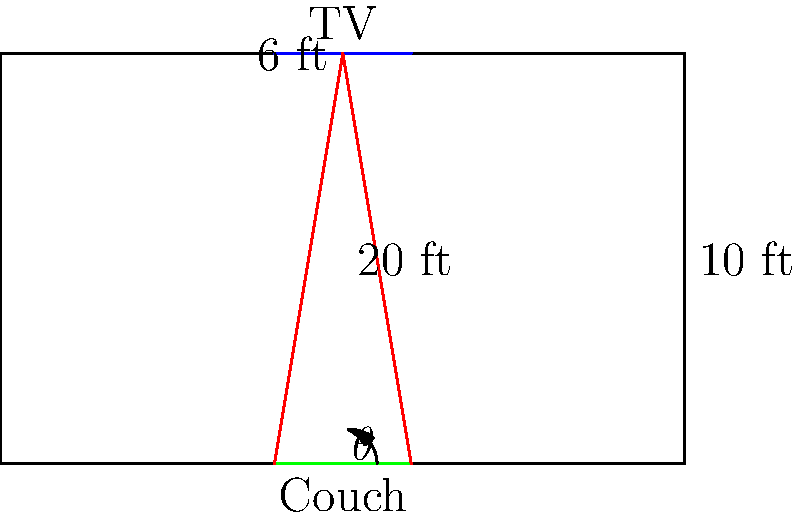As you prepare for the next Vikings game watch party, you want to ensure optimal TV placement in your rectangular living room. The room is 10 feet wide and 20 feet long, with a 6-foot ceiling height. You plan to mount a large TV centered on the short wall and place a couch directly opposite, also centered. If the optimal viewing angle is 30 degrees, how far should the couch be placed from the TV wall to achieve this angle? Round your answer to the nearest foot. Let's approach this step-by-step:

1) First, we need to understand what the viewing angle means. It's the angle formed between two lines from the edges of the TV to the viewer's eyes.

2) In this case, we're looking for the distance from the wall where this angle is 30 degrees.

3) We can split this angle into two right triangles. Each will have an angle of 15 degrees (half of 30).

4) In these triangles:
   - The opposite side is half the height of the room (3 feet)
   - The adjacent side is the distance we're looking for (let's call it $x$)

5) We can use the tangent function to solve for $x$:

   $\tan(15°) = \frac{\text{opposite}}{\text{adjacent}} = \frac{3}{x}$

6) Rearranging this equation:

   $x = \frac{3}{\tan(15°)}$

7) Now let's calculate:
   
   $x = \frac{3}{\tan(15°)} \approx 11.18$ feet

8) Rounding to the nearest foot gives us 11 feet.
Answer: 11 feet 